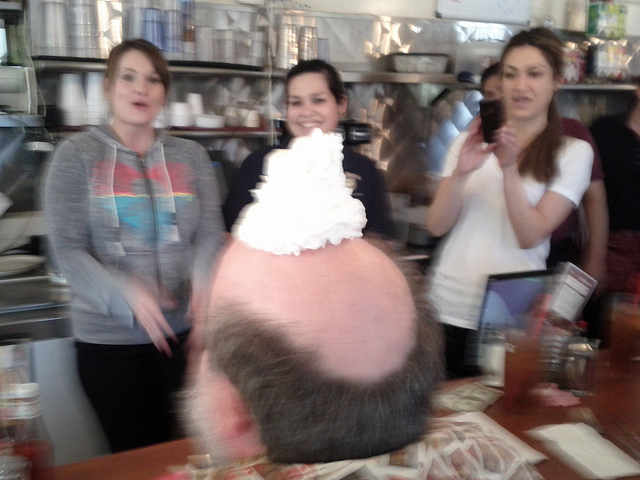What can we infer about the location where this image was taken? Considering the shelving with dishes in the background and the table setting, we can infer that this image was taken at a dining establishment, likely a cafe or diner. The casual dress of the patrons and the visibility of items like condiment bottles strengthen the impression of a laid-back, communal dining experience. 